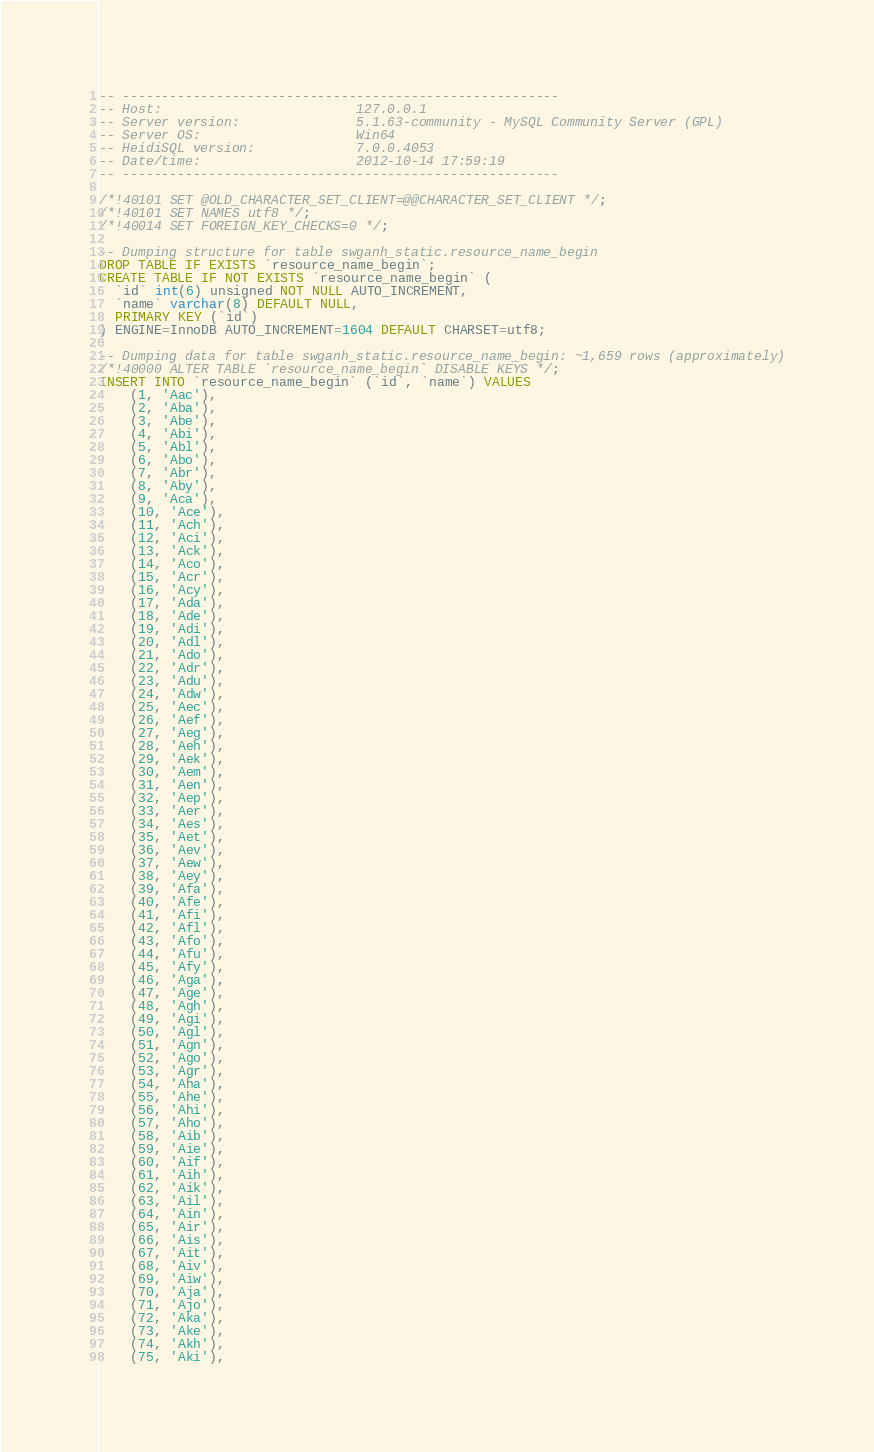<code> <loc_0><loc_0><loc_500><loc_500><_SQL_>-- --------------------------------------------------------
-- Host:                         127.0.0.1
-- Server version:               5.1.63-community - MySQL Community Server (GPL)
-- Server OS:                    Win64
-- HeidiSQL version:             7.0.0.4053
-- Date/time:                    2012-10-14 17:59:19
-- --------------------------------------------------------

/*!40101 SET @OLD_CHARACTER_SET_CLIENT=@@CHARACTER_SET_CLIENT */;
/*!40101 SET NAMES utf8 */;
/*!40014 SET FOREIGN_KEY_CHECKS=0 */;

-- Dumping structure for table swganh_static.resource_name_begin
DROP TABLE IF EXISTS `resource_name_begin`;
CREATE TABLE IF NOT EXISTS `resource_name_begin` (
  `id` int(6) unsigned NOT NULL AUTO_INCREMENT,
  `name` varchar(8) DEFAULT NULL,
  PRIMARY KEY (`id`)
) ENGINE=InnoDB AUTO_INCREMENT=1604 DEFAULT CHARSET=utf8;

-- Dumping data for table swganh_static.resource_name_begin: ~1,659 rows (approximately)
/*!40000 ALTER TABLE `resource_name_begin` DISABLE KEYS */;
INSERT INTO `resource_name_begin` (`id`, `name`) VALUES
	(1, 'Aac'),
	(2, 'Aba'),
	(3, 'Abe'),
	(4, 'Abi'),
	(5, 'Abl'),
	(6, 'Abo'),
	(7, 'Abr'),
	(8, 'Aby'),
	(9, 'Aca'),
	(10, 'Ace'),
	(11, 'Ach'),
	(12, 'Aci'),
	(13, 'Ack'),
	(14, 'Aco'),
	(15, 'Acr'),
	(16, 'Acy'),
	(17, 'Ada'),
	(18, 'Ade'),
	(19, 'Adi'),
	(20, 'Adl'),
	(21, 'Ado'),
	(22, 'Adr'),
	(23, 'Adu'),
	(24, 'Adw'),
	(25, 'Aec'),
	(26, 'Aef'),
	(27, 'Aeg'),
	(28, 'Aeh'),
	(29, 'Aek'),
	(30, 'Aem'),
	(31, 'Aen'),
	(32, 'Aep'),
	(33, 'Aer'),
	(34, 'Aes'),
	(35, 'Aet'),
	(36, 'Aev'),
	(37, 'Aew'),
	(38, 'Aey'),
	(39, 'Afa'),
	(40, 'Afe'),
	(41, 'Afi'),
	(42, 'Afl'),
	(43, 'Afo'),
	(44, 'Afu'),
	(45, 'Afy'),
	(46, 'Aga'),
	(47, 'Age'),
	(48, 'Agh'),
	(49, 'Agi'),
	(50, 'Agl'),
	(51, 'Agn'),
	(52, 'Ago'),
	(53, 'Agr'),
	(54, 'Aha'),
	(55, 'Ahe'),
	(56, 'Ahi'),
	(57, 'Aho'),
	(58, 'Aib'),
	(59, 'Aie'),
	(60, 'Aif'),
	(61, 'Aih'),
	(62, 'Aik'),
	(63, 'Ail'),
	(64, 'Ain'),
	(65, 'Air'),
	(66, 'Ais'),
	(67, 'Ait'),
	(68, 'Aiv'),
	(69, 'Aiw'),
	(70, 'Aja'),
	(71, 'Ajo'),
	(72, 'Aka'),
	(73, 'Ake'),
	(74, 'Akh'),
	(75, 'Aki'),</code> 